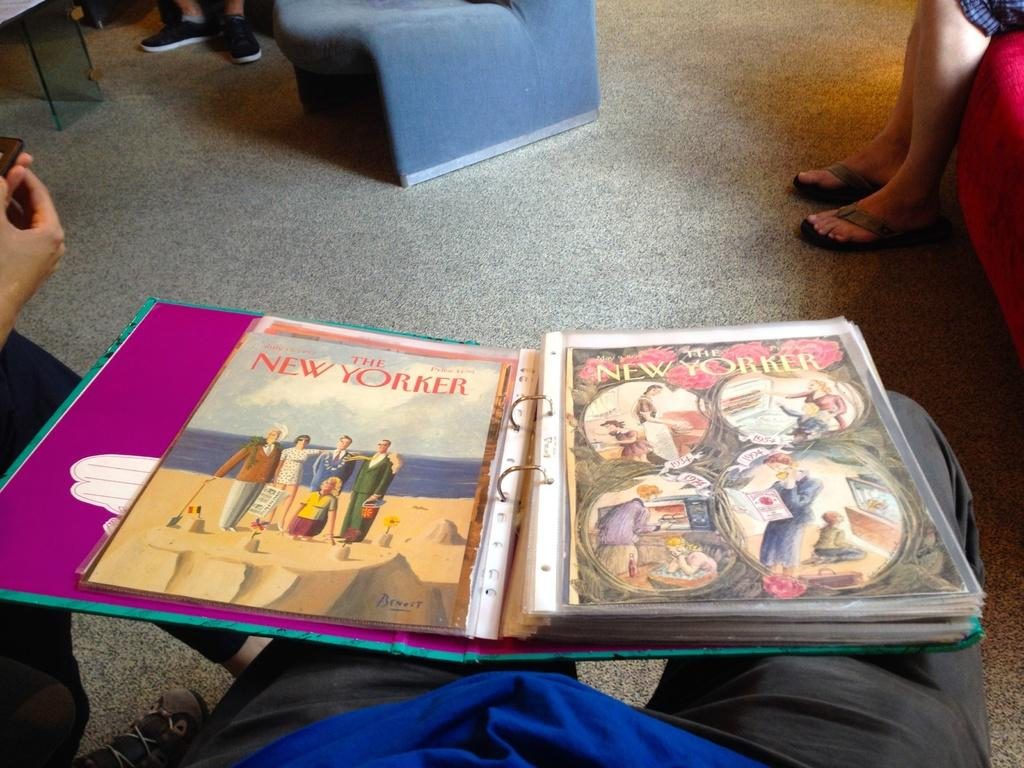Provide a one-sentence caption for the provided image. a magazine with New Yorker written on it. 